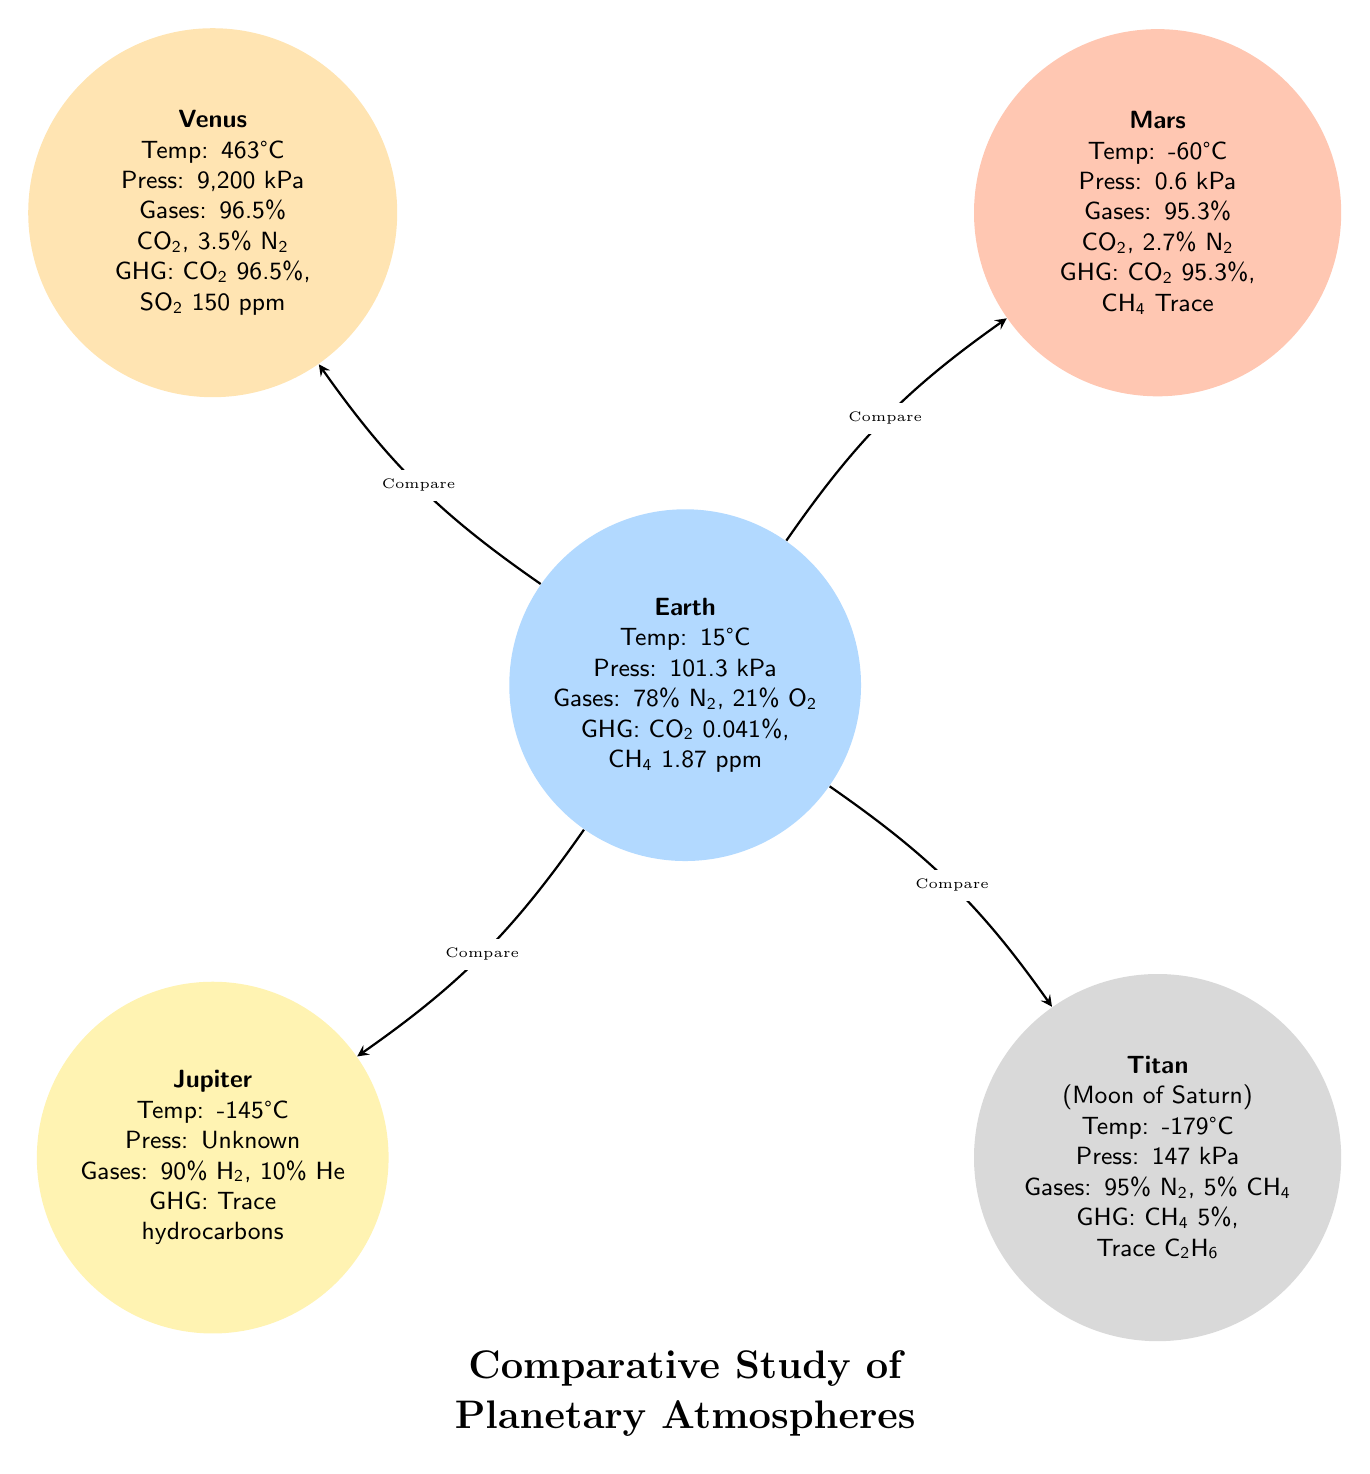What is the temperature on Venus? According to the diagram, Venus has a recorded temperature of 463°C.
Answer: 463°C What is the primary greenhouse gas on Mars? The chart indicates that the primary greenhouse gas on Mars is CO2 at 95.3%.
Answer: CO2 95.3% How many planets are compared in the diagram? The diagram includes Earth, Venus, Mars, Jupiter, and Titan, which totals to five planets.
Answer: 5 What is the atmospheric pressure on Titan? The diagram states that Titan has an atmospheric pressure of 147 kPa.
Answer: 147 kPa Which planet has the highest average temperature? From the information provided, Venus has the highest temperature at 463°C, compared to other planets in the diagram.
Answer: Venus What are the main gases present in Earth's atmosphere? The chart details that Earth's atmosphere is composed of 78% N2 and 21% O2.
Answer: 78% N2, 21% O2 Which of the following planets has trace amounts of hydrocarbons as greenhouse gases? The diagram specifies that Jupiter has trace hydrocarbons in its atmosphere as greenhouse gases.
Answer: Jupiter How do the greenhouse gas concentrations of Earth compare to those of Venus? Looking at the chart, Venus has a greenhouse gas concentration of 96.5% CO2, far exceeding Earth's 0.041% CO2 and 1.87 ppm CH4.
Answer: Venus has higher concentrations What is the average temperature of Jupiter? According to the diagram, Jupiter's average temperature is -145°C.
Answer: -145°C 